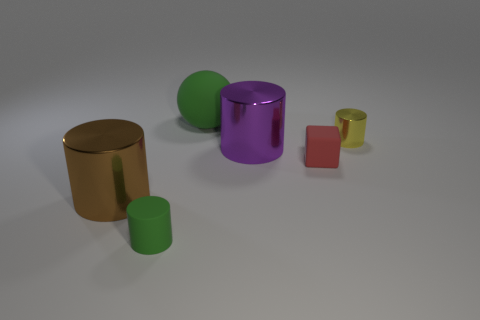Subtract all shiny cylinders. How many cylinders are left? 1 Add 1 tiny red shiny cylinders. How many objects exist? 7 Subtract all purple cylinders. How many cylinders are left? 3 Subtract 3 cylinders. How many cylinders are left? 1 Subtract all cylinders. How many objects are left? 2 Subtract all big green matte balls. Subtract all tiny green cylinders. How many objects are left? 4 Add 1 large green rubber objects. How many large green rubber objects are left? 2 Add 2 large purple shiny cylinders. How many large purple shiny cylinders exist? 3 Subtract 0 gray blocks. How many objects are left? 6 Subtract all purple spheres. Subtract all cyan cylinders. How many spheres are left? 1 